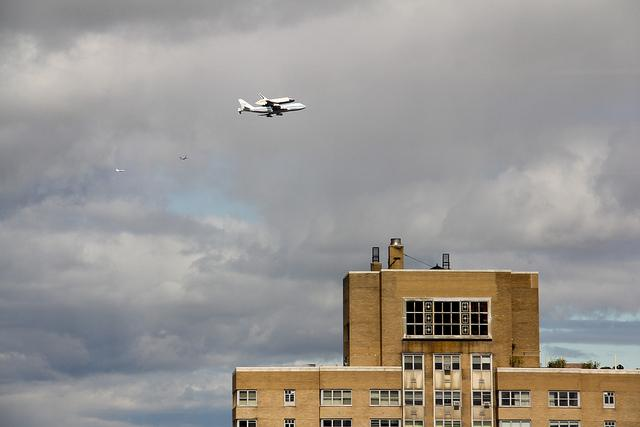What is the plane flying over? Please explain your reasoning. building. The plane is flying over a tall man-made object that has lots of windows. 